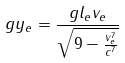Convert formula to latex. <formula><loc_0><loc_0><loc_500><loc_500>g y _ { e } = \frac { g l _ { e } v _ { e } } { \sqrt { 9 - \frac { v _ { e } ^ { 7 } } { c ^ { 7 } } } }</formula> 